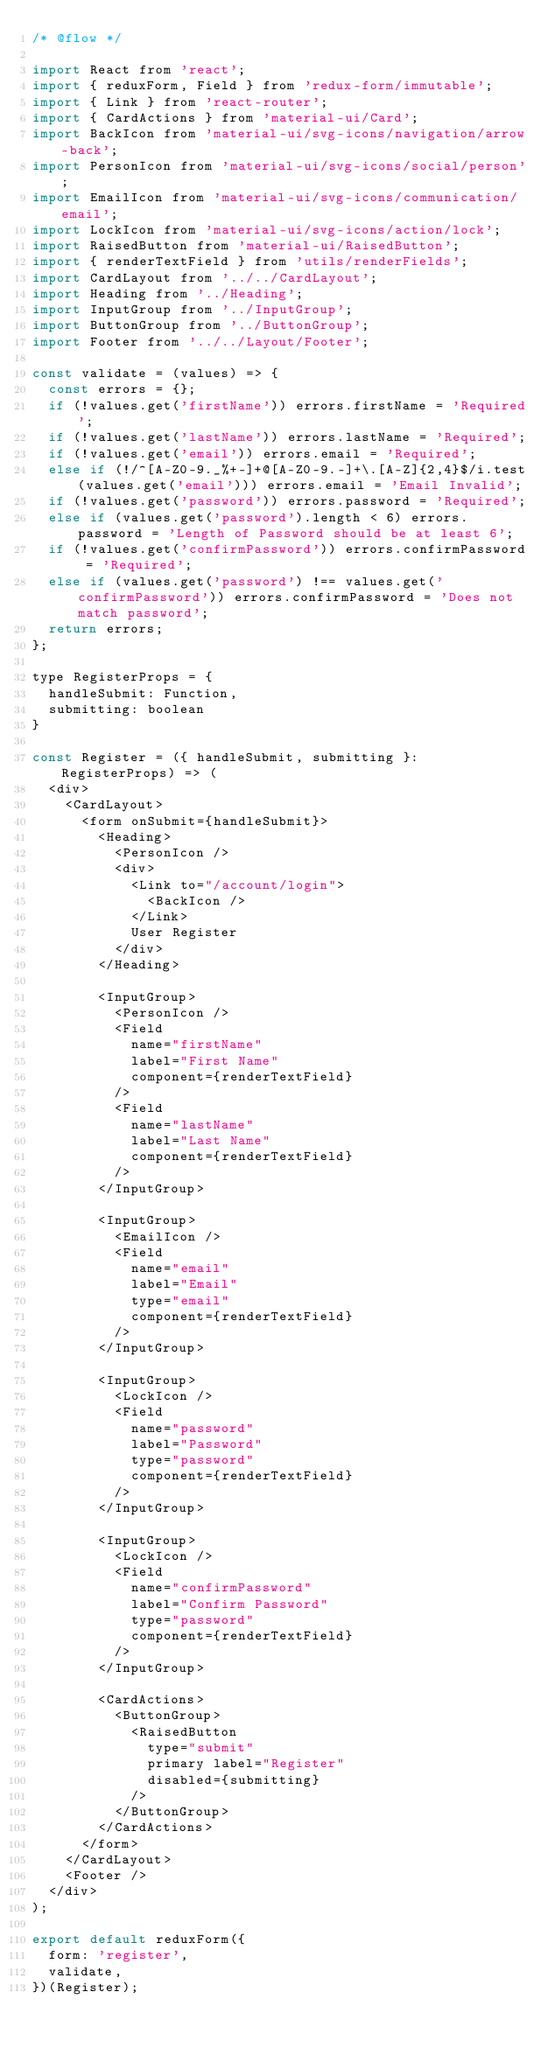Convert code to text. <code><loc_0><loc_0><loc_500><loc_500><_JavaScript_>/* @flow */

import React from 'react';
import { reduxForm, Field } from 'redux-form/immutable';
import { Link } from 'react-router';
import { CardActions } from 'material-ui/Card';
import BackIcon from 'material-ui/svg-icons/navigation/arrow-back';
import PersonIcon from 'material-ui/svg-icons/social/person';
import EmailIcon from 'material-ui/svg-icons/communication/email';
import LockIcon from 'material-ui/svg-icons/action/lock';
import RaisedButton from 'material-ui/RaisedButton';
import { renderTextField } from 'utils/renderFields';
import CardLayout from '../../CardLayout';
import Heading from '../Heading';
import InputGroup from '../InputGroup';
import ButtonGroup from '../ButtonGroup';
import Footer from '../../Layout/Footer';

const validate = (values) => {
  const errors = {};
  if (!values.get('firstName')) errors.firstName = 'Required';
  if (!values.get('lastName')) errors.lastName = 'Required';
  if (!values.get('email')) errors.email = 'Required';
  else if (!/^[A-Z0-9._%+-]+@[A-Z0-9.-]+\.[A-Z]{2,4}$/i.test(values.get('email'))) errors.email = 'Email Invalid';
  if (!values.get('password')) errors.password = 'Required';
  else if (values.get('password').length < 6) errors.password = 'Length of Password should be at least 6';
  if (!values.get('confirmPassword')) errors.confirmPassword = 'Required';
  else if (values.get('password') !== values.get('confirmPassword')) errors.confirmPassword = 'Does not match password';
  return errors;
};

type RegisterProps = {
  handleSubmit: Function,
  submitting: boolean
}

const Register = ({ handleSubmit, submitting }: RegisterProps) => (
  <div>
    <CardLayout>
      <form onSubmit={handleSubmit}>
        <Heading>
          <PersonIcon />
          <div>
            <Link to="/account/login">
              <BackIcon />
            </Link>
            User Register
          </div>
        </Heading>

        <InputGroup>
          <PersonIcon />
          <Field
            name="firstName"
            label="First Name"
            component={renderTextField}
          />
          <Field
            name="lastName"
            label="Last Name"
            component={renderTextField}
          />
        </InputGroup>

        <InputGroup>
          <EmailIcon />
          <Field
            name="email"
            label="Email"
            type="email"
            component={renderTextField}
          />
        </InputGroup>

        <InputGroup>
          <LockIcon />
          <Field
            name="password"
            label="Password"
            type="password"
            component={renderTextField}
          />
        </InputGroup>

        <InputGroup>
          <LockIcon />
          <Field
            name="confirmPassword"
            label="Confirm Password"
            type="password"
            component={renderTextField}
          />
        </InputGroup>

        <CardActions>
          <ButtonGroup>
            <RaisedButton
              type="submit"
              primary label="Register"
              disabled={submitting}
            />
          </ButtonGroup>
        </CardActions>
      </form>
    </CardLayout>
    <Footer />
  </div>
);

export default reduxForm({
  form: 'register',
  validate,
})(Register);
</code> 